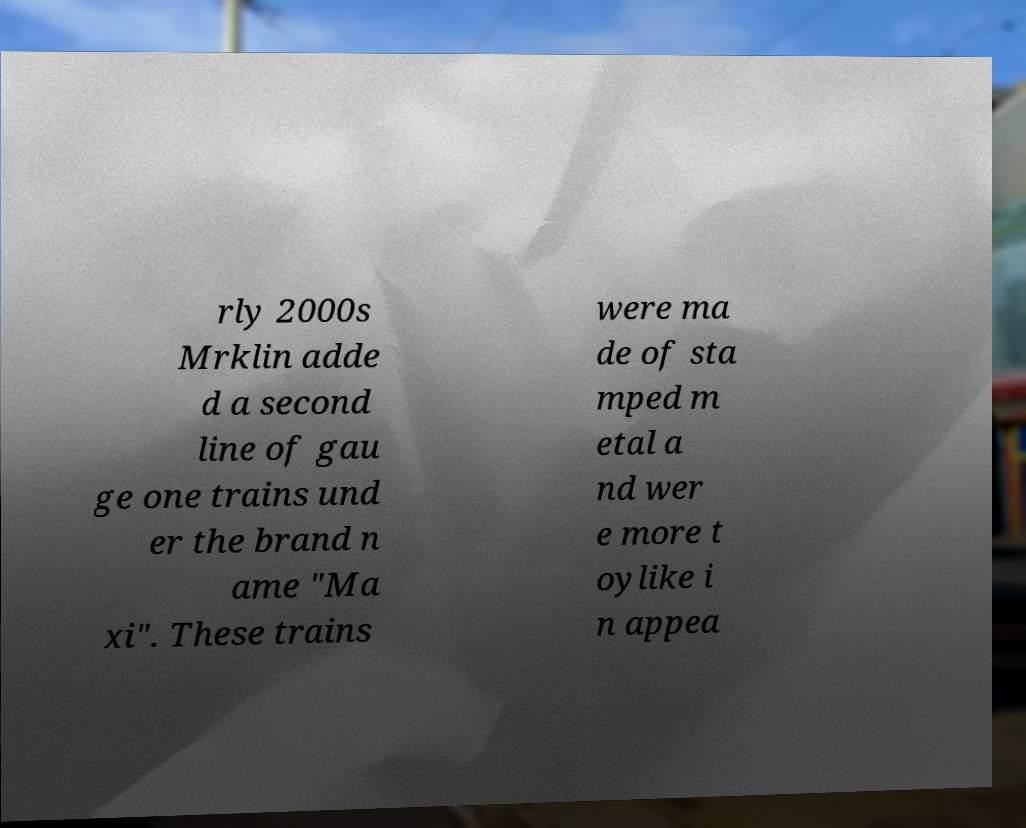Could you extract and type out the text from this image? rly 2000s Mrklin adde d a second line of gau ge one trains und er the brand n ame "Ma xi". These trains were ma de of sta mped m etal a nd wer e more t oylike i n appea 